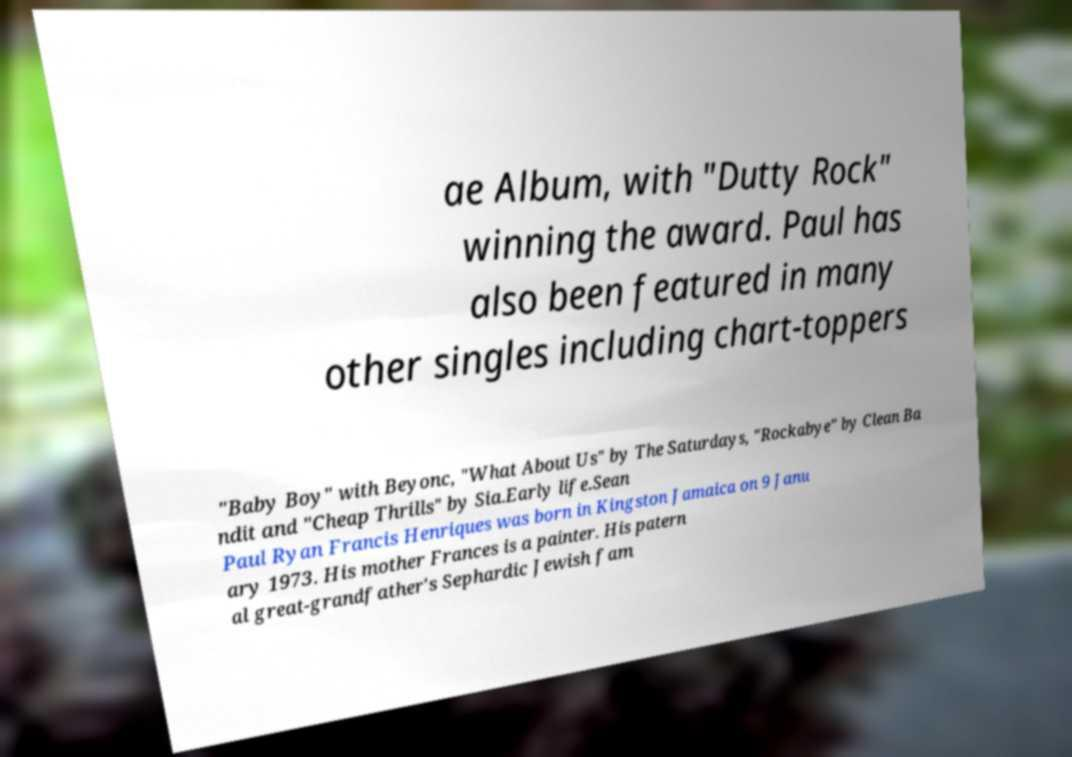Could you assist in decoding the text presented in this image and type it out clearly? ae Album, with "Dutty Rock" winning the award. Paul has also been featured in many other singles including chart-toppers "Baby Boy" with Beyonc, "What About Us" by The Saturdays, "Rockabye" by Clean Ba ndit and "Cheap Thrills" by Sia.Early life.Sean Paul Ryan Francis Henriques was born in Kingston Jamaica on 9 Janu ary 1973. His mother Frances is a painter. His patern al great-grandfather's Sephardic Jewish fam 